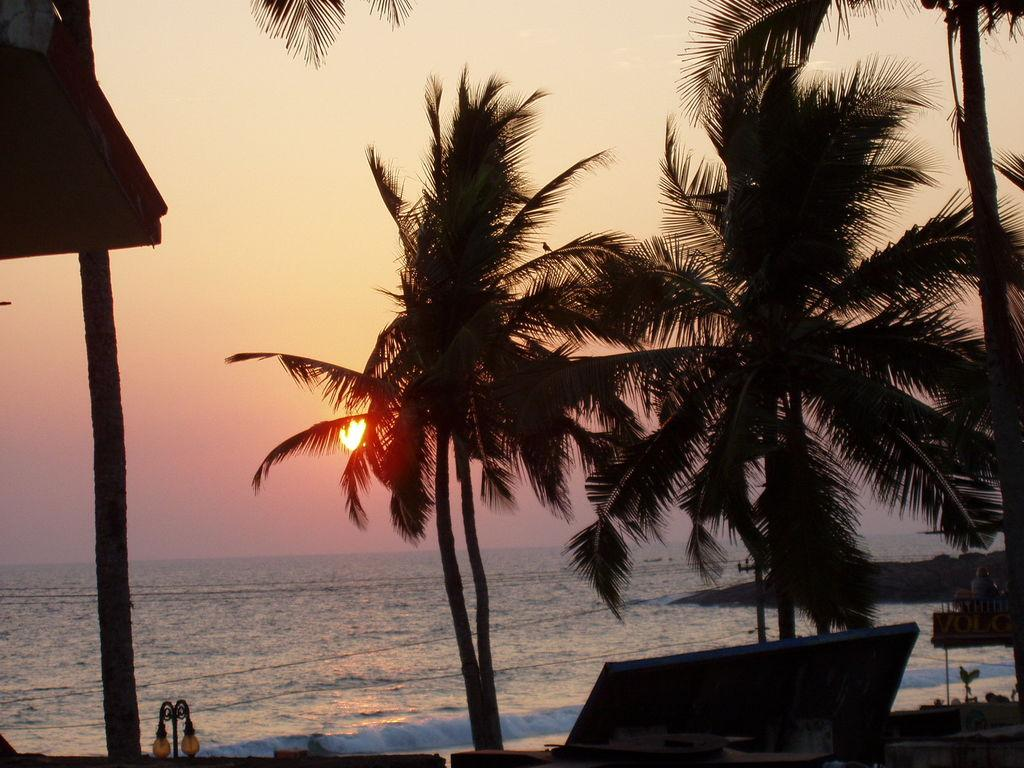What type of vegetation can be seen in the image? There are trees in the image. What is located at the bottom of the image? There is water at the bottom of the image. What can be seen in the background of the image? The sky is visible in the background of the image. What celestial body is observable in the sky? The sun is observable in the sky. What type of powder can be seen falling from the trees in the image? There is no powder falling from the trees in the image; it only features trees, water, and the sky. 